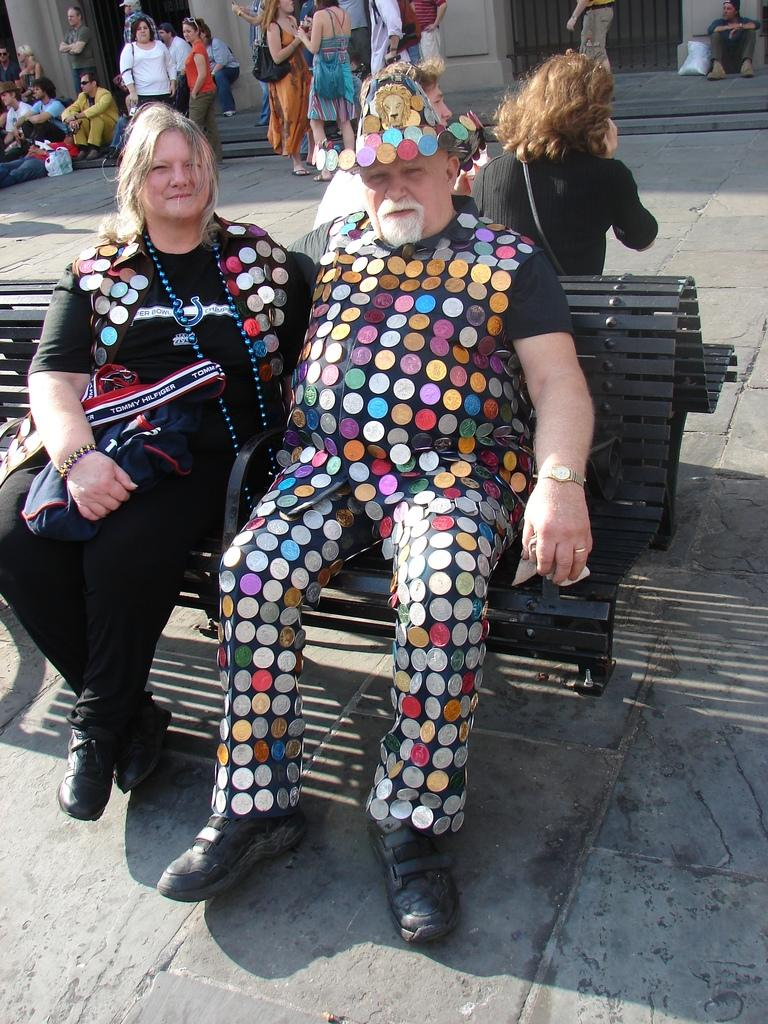What are the main subjects in the middle of the image? There are persons sitting on a bench in the middle of the image. What are the people at the top of the image doing? There are people standing and sitting at the top of the image. What can be seen in the background of the image? There is a building visible in the background of the image. What type of lock can be seen on the plane in the image? There is no plane present in the image, so there is no lock to be seen on a plane. 